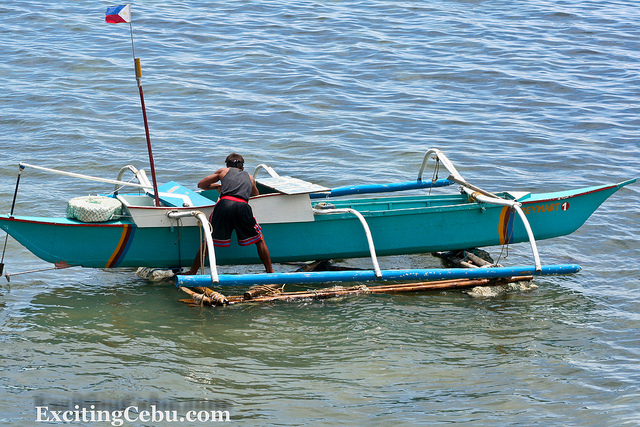<image>What is the person doing on the side of the boat? It is unclear what the person on the side of the boat is doing, they could be doing various actions like putting fish in the hold, looking for something, or just standing. What is the person doing on the side of the boat? I don't know what the person is doing on the side of the boat. It can be any of the given options. 